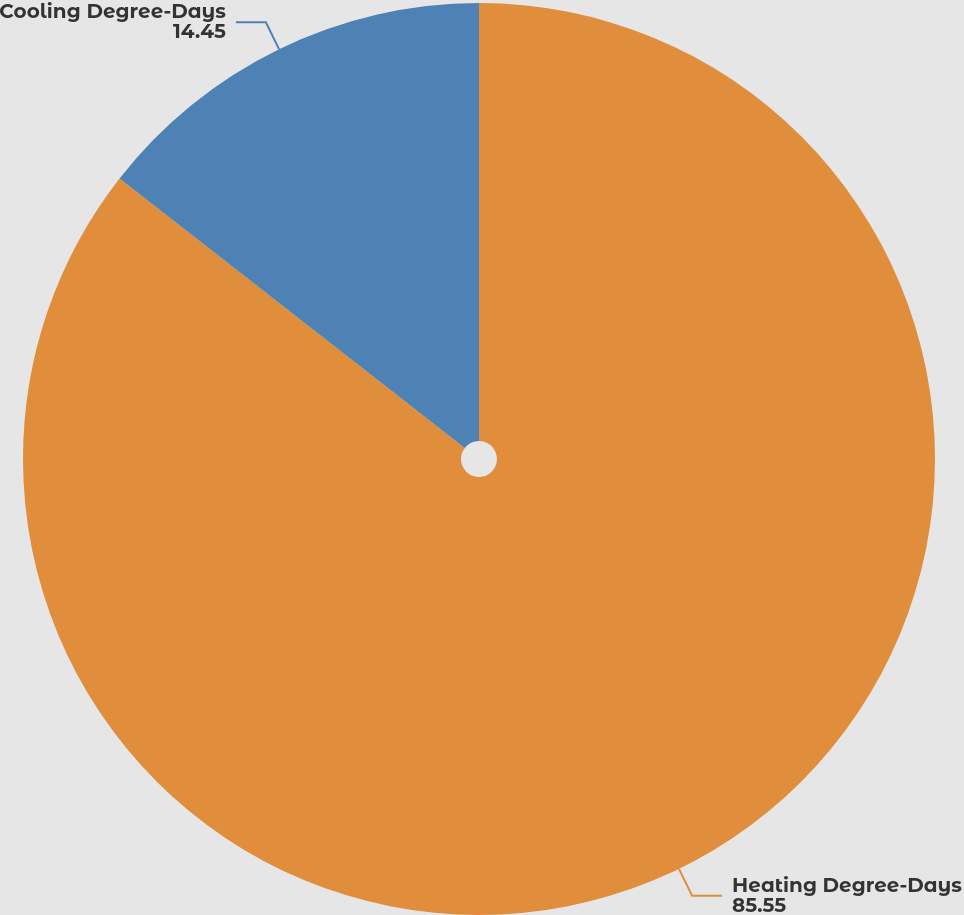Convert chart to OTSL. <chart><loc_0><loc_0><loc_500><loc_500><pie_chart><fcel>Heating Degree-Days<fcel>Cooling Degree-Days<nl><fcel>85.55%<fcel>14.45%<nl></chart> 